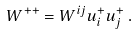<formula> <loc_0><loc_0><loc_500><loc_500>W ^ { + + } = W ^ { i j } u ^ { + } _ { i } u ^ { + } _ { j } \, .</formula> 